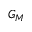Convert formula to latex. <formula><loc_0><loc_0><loc_500><loc_500>G _ { M }</formula> 